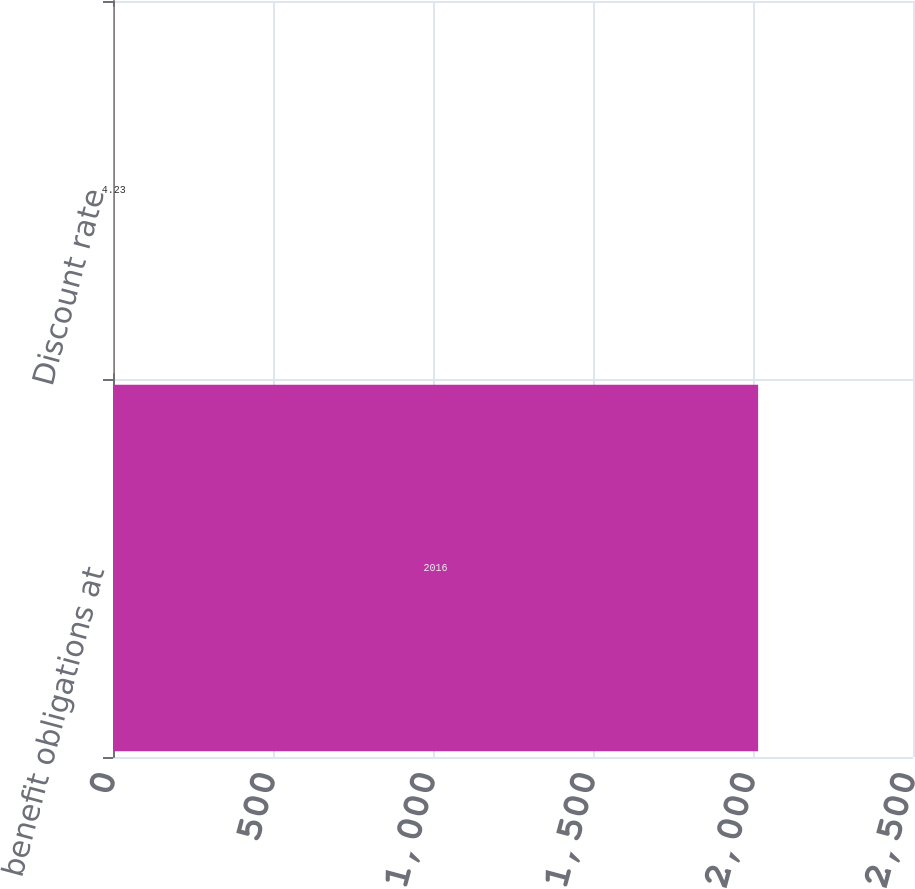<chart> <loc_0><loc_0><loc_500><loc_500><bar_chart><fcel>benefit obligations at<fcel>Discount rate<nl><fcel>2016<fcel>4.23<nl></chart> 